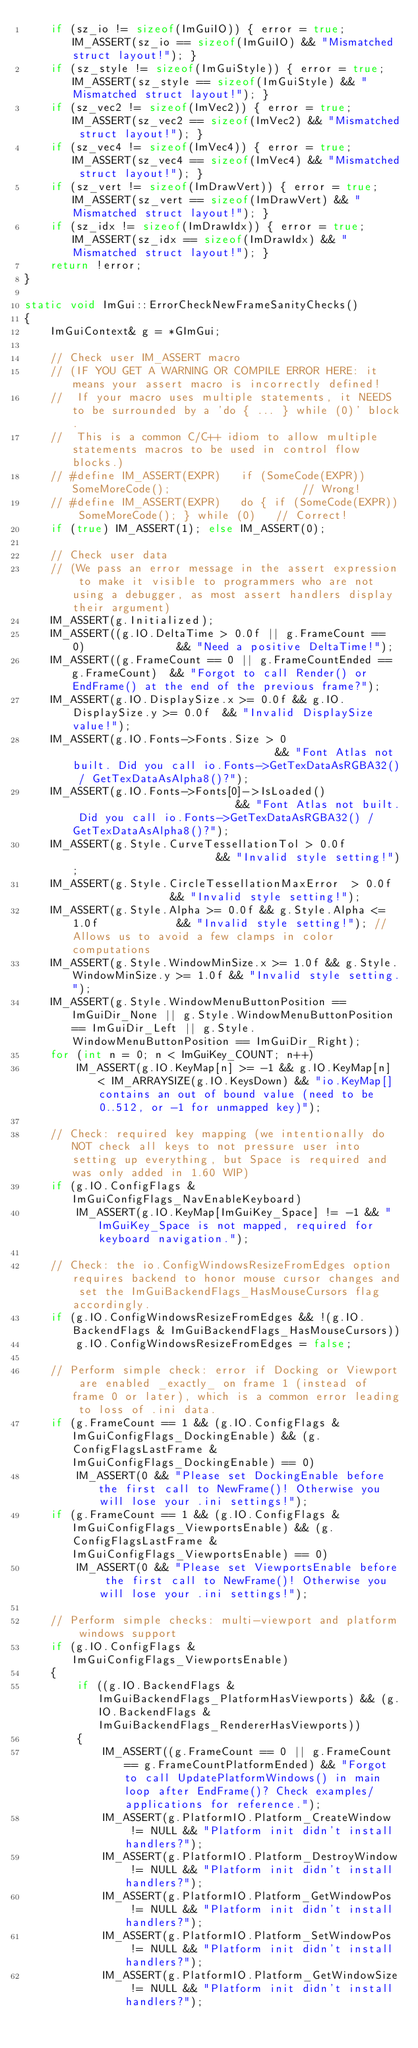Convert code to text. <code><loc_0><loc_0><loc_500><loc_500><_C++_>    if (sz_io != sizeof(ImGuiIO)) { error = true; IM_ASSERT(sz_io == sizeof(ImGuiIO) && "Mismatched struct layout!"); }
    if (sz_style != sizeof(ImGuiStyle)) { error = true; IM_ASSERT(sz_style == sizeof(ImGuiStyle) && "Mismatched struct layout!"); }
    if (sz_vec2 != sizeof(ImVec2)) { error = true; IM_ASSERT(sz_vec2 == sizeof(ImVec2) && "Mismatched struct layout!"); }
    if (sz_vec4 != sizeof(ImVec4)) { error = true; IM_ASSERT(sz_vec4 == sizeof(ImVec4) && "Mismatched struct layout!"); }
    if (sz_vert != sizeof(ImDrawVert)) { error = true; IM_ASSERT(sz_vert == sizeof(ImDrawVert) && "Mismatched struct layout!"); }
    if (sz_idx != sizeof(ImDrawIdx)) { error = true; IM_ASSERT(sz_idx == sizeof(ImDrawIdx) && "Mismatched struct layout!"); }
    return !error;
}

static void ImGui::ErrorCheckNewFrameSanityChecks()
{
    ImGuiContext& g = *GImGui;

    // Check user IM_ASSERT macro
    // (IF YOU GET A WARNING OR COMPILE ERROR HERE: it means your assert macro is incorrectly defined!
    //  If your macro uses multiple statements, it NEEDS to be surrounded by a 'do { ... } while (0)' block.
    //  This is a common C/C++ idiom to allow multiple statements macros to be used in control flow blocks.)
    // #define IM_ASSERT(EXPR)   if (SomeCode(EXPR)) SomeMoreCode();                    // Wrong!
    // #define IM_ASSERT(EXPR)   do { if (SomeCode(EXPR)) SomeMoreCode(); } while (0)   // Correct!
    if (true) IM_ASSERT(1); else IM_ASSERT(0);

    // Check user data
    // (We pass an error message in the assert expression to make it visible to programmers who are not using a debugger, as most assert handlers display their argument)
    IM_ASSERT(g.Initialized);
    IM_ASSERT((g.IO.DeltaTime > 0.0f || g.FrameCount == 0)              && "Need a positive DeltaTime!");
    IM_ASSERT((g.FrameCount == 0 || g.FrameCountEnded == g.FrameCount)  && "Forgot to call Render() or EndFrame() at the end of the previous frame?");
    IM_ASSERT(g.IO.DisplaySize.x >= 0.0f && g.IO.DisplaySize.y >= 0.0f  && "Invalid DisplaySize value!");
    IM_ASSERT(g.IO.Fonts->Fonts.Size > 0                                && "Font Atlas not built. Did you call io.Fonts->GetTexDataAsRGBA32() / GetTexDataAsAlpha8()?");
    IM_ASSERT(g.IO.Fonts->Fonts[0]->IsLoaded()                          && "Font Atlas not built. Did you call io.Fonts->GetTexDataAsRGBA32() / GetTexDataAsAlpha8()?");
    IM_ASSERT(g.Style.CurveTessellationTol > 0.0f                       && "Invalid style setting!");
    IM_ASSERT(g.Style.CircleTessellationMaxError  > 0.0f                && "Invalid style setting!");
    IM_ASSERT(g.Style.Alpha >= 0.0f && g.Style.Alpha <= 1.0f            && "Invalid style setting!"); // Allows us to avoid a few clamps in color computations
    IM_ASSERT(g.Style.WindowMinSize.x >= 1.0f && g.Style.WindowMinSize.y >= 1.0f && "Invalid style setting.");
    IM_ASSERT(g.Style.WindowMenuButtonPosition == ImGuiDir_None || g.Style.WindowMenuButtonPosition == ImGuiDir_Left || g.Style.WindowMenuButtonPosition == ImGuiDir_Right);
    for (int n = 0; n < ImGuiKey_COUNT; n++)
        IM_ASSERT(g.IO.KeyMap[n] >= -1 && g.IO.KeyMap[n] < IM_ARRAYSIZE(g.IO.KeysDown) && "io.KeyMap[] contains an out of bound value (need to be 0..512, or -1 for unmapped key)");

    // Check: required key mapping (we intentionally do NOT check all keys to not pressure user into setting up everything, but Space is required and was only added in 1.60 WIP)
    if (g.IO.ConfigFlags & ImGuiConfigFlags_NavEnableKeyboard)
        IM_ASSERT(g.IO.KeyMap[ImGuiKey_Space] != -1 && "ImGuiKey_Space is not mapped, required for keyboard navigation.");

    // Check: the io.ConfigWindowsResizeFromEdges option requires backend to honor mouse cursor changes and set the ImGuiBackendFlags_HasMouseCursors flag accordingly.
    if (g.IO.ConfigWindowsResizeFromEdges && !(g.IO.BackendFlags & ImGuiBackendFlags_HasMouseCursors))
        g.IO.ConfigWindowsResizeFromEdges = false;

    // Perform simple check: error if Docking or Viewport are enabled _exactly_ on frame 1 (instead of frame 0 or later), which is a common error leading to loss of .ini data.
    if (g.FrameCount == 1 && (g.IO.ConfigFlags & ImGuiConfigFlags_DockingEnable) && (g.ConfigFlagsLastFrame & ImGuiConfigFlags_DockingEnable) == 0)
        IM_ASSERT(0 && "Please set DockingEnable before the first call to NewFrame()! Otherwise you will lose your .ini settings!");
    if (g.FrameCount == 1 && (g.IO.ConfigFlags & ImGuiConfigFlags_ViewportsEnable) && (g.ConfigFlagsLastFrame & ImGuiConfigFlags_ViewportsEnable) == 0)
        IM_ASSERT(0 && "Please set ViewportsEnable before the first call to NewFrame()! Otherwise you will lose your .ini settings!");

    // Perform simple checks: multi-viewport and platform windows support
    if (g.IO.ConfigFlags & ImGuiConfigFlags_ViewportsEnable)
    {
        if ((g.IO.BackendFlags & ImGuiBackendFlags_PlatformHasViewports) && (g.IO.BackendFlags & ImGuiBackendFlags_RendererHasViewports))
        {
            IM_ASSERT((g.FrameCount == 0 || g.FrameCount == g.FrameCountPlatformEnded) && "Forgot to call UpdatePlatformWindows() in main loop after EndFrame()? Check examples/ applications for reference.");
            IM_ASSERT(g.PlatformIO.Platform_CreateWindow  != NULL && "Platform init didn't install handlers?");
            IM_ASSERT(g.PlatformIO.Platform_DestroyWindow != NULL && "Platform init didn't install handlers?");
            IM_ASSERT(g.PlatformIO.Platform_GetWindowPos  != NULL && "Platform init didn't install handlers?");
            IM_ASSERT(g.PlatformIO.Platform_SetWindowPos  != NULL && "Platform init didn't install handlers?");
            IM_ASSERT(g.PlatformIO.Platform_GetWindowSize != NULL && "Platform init didn't install handlers?");</code> 